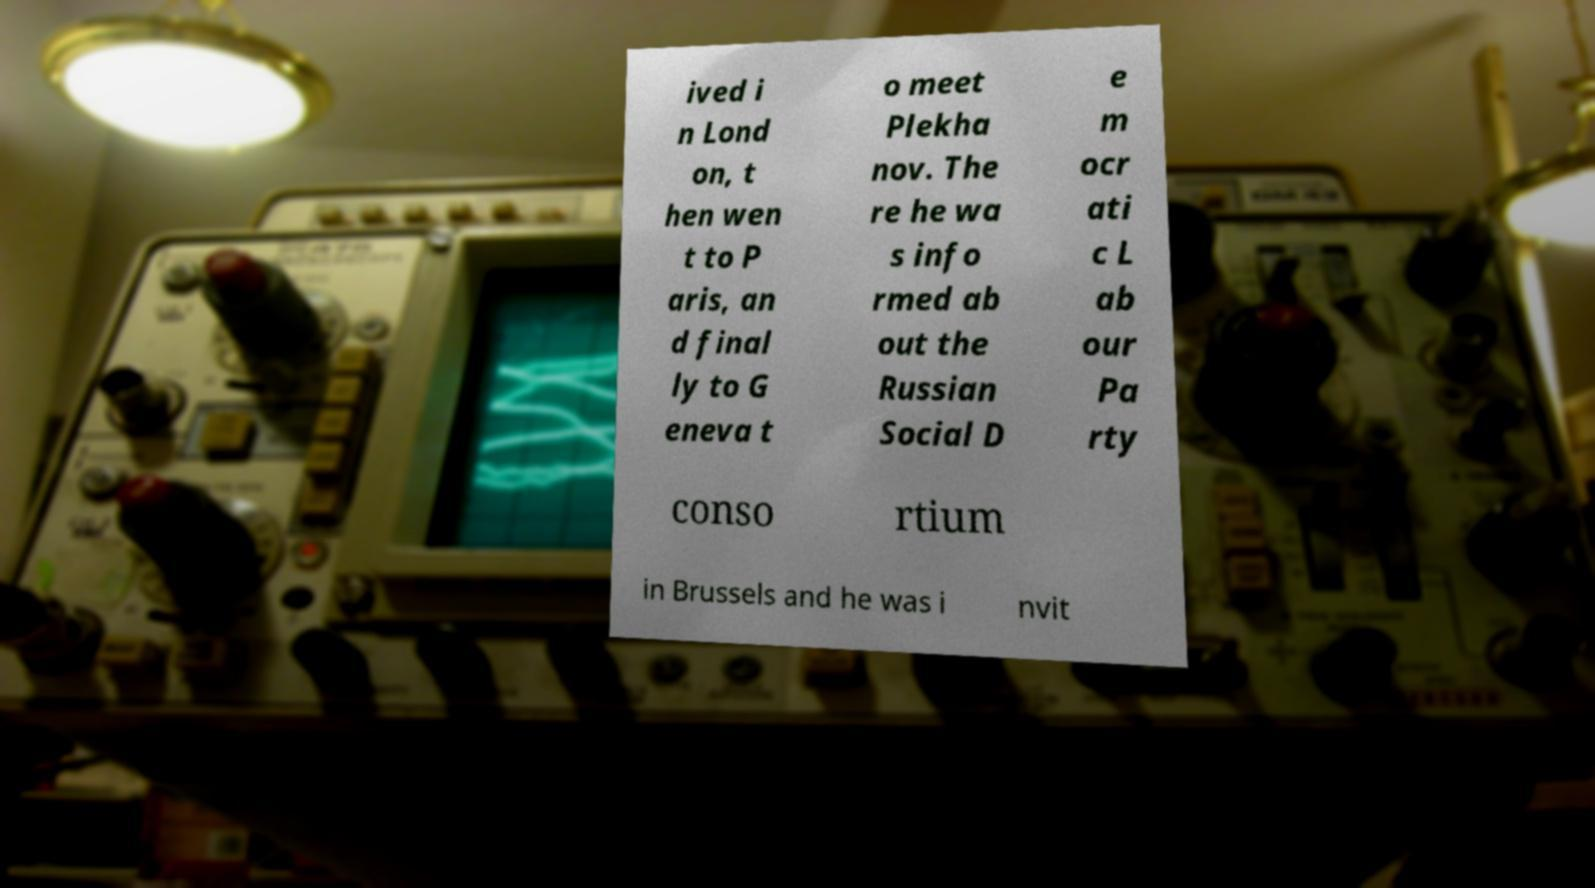For documentation purposes, I need the text within this image transcribed. Could you provide that? ived i n Lond on, t hen wen t to P aris, an d final ly to G eneva t o meet Plekha nov. The re he wa s info rmed ab out the Russian Social D e m ocr ati c L ab our Pa rty conso rtium in Brussels and he was i nvit 